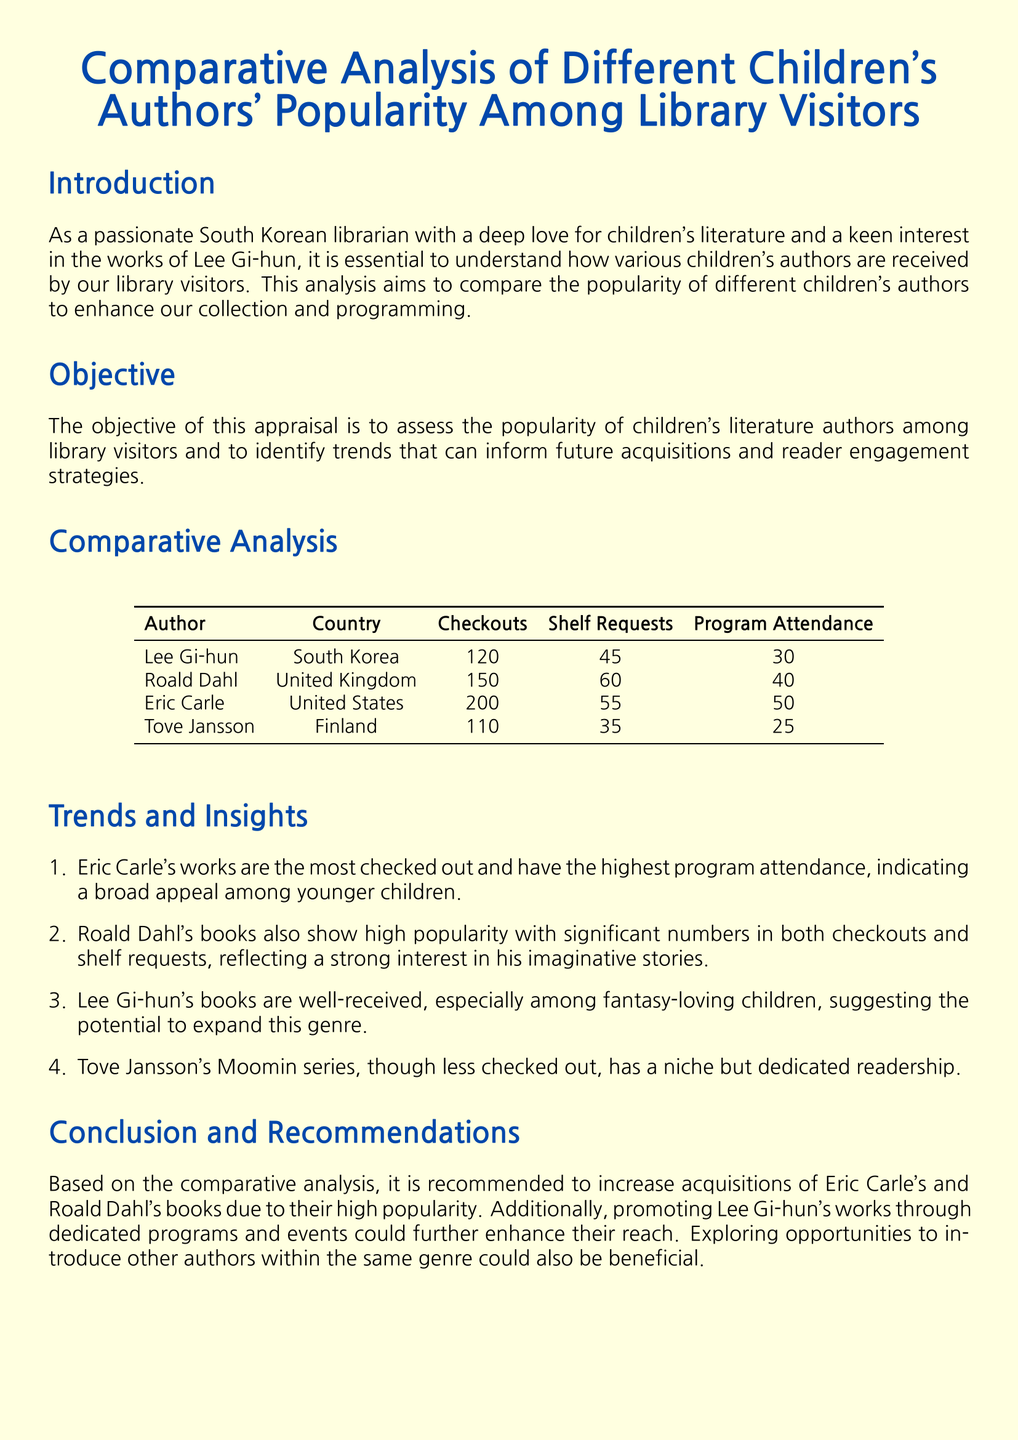What is the name of the South Korean author analyzed? The analysis specifically mentions Lee Gi-hun as the South Korean author being assessed.
Answer: Lee Gi-hun Which author's works are checked out the most? The document indicates that Eric Carle has the highest checkouts among the authors listed.
Answer: Eric Carle How many shelf requests does Roald Dahl have? The information in the document states that Roald Dahl received 60 shelf requests.
Answer: 60 What is the program attendance for Tove Jansson? The document provides that Tove Jansson's program attendance is 25.
Answer: 25 Which author’s books have a strong interest reflected in shelf requests? The high number of shelf requests for Roald Dahl reflects strong interest in his books.
Answer: Roald Dahl What is the total number of checkouts for Lee Gi-hun? The document lists 120 checkouts for Lee Gi-hun contributing to the analysis.
Answer: 120 Which author's works indicate a broad appeal among younger children? The analysis highlights Eric Carle's works as appealing broadly to younger children.
Answer: Eric Carle What recommendation is made for Lee Gi-hun's works? The document recommends promoting Lee Gi-hun's works through dedicated programs and events.
Answer: Promoting through dedicated programs What genre does Lee Gi-hun's work cater to? The analysis suggests that Lee Gi-hun's works appeal to fantasy-loving children.
Answer: Fantasy 